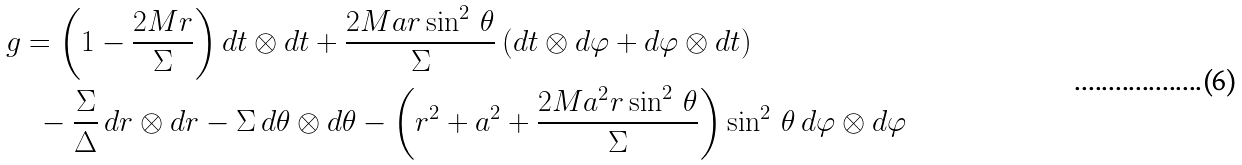Convert formula to latex. <formula><loc_0><loc_0><loc_500><loc_500>& g = \left ( 1 - \frac { 2 M r } { \Sigma } \right ) d t \otimes d t + \frac { 2 M a r \sin ^ { 2 } \, \theta } { \Sigma } \, ( d t \otimes d \varphi + d \varphi \otimes d t ) \\ & \quad - \frac { \Sigma } { \Delta } \, d r \otimes d r - \Sigma \, d \theta \otimes d \theta - \left ( r ^ { 2 } + a ^ { 2 } + \frac { 2 M a ^ { 2 } r \sin ^ { 2 } \, \theta } { \Sigma } \right ) \sin ^ { 2 } \, \theta \, d \varphi \otimes d \varphi</formula> 